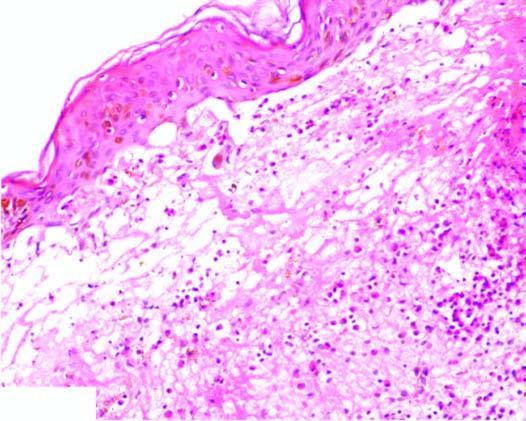do the lumen show neutrophilic microabscess causing dermo-epidermal separation at tips?
Answer the question using a single word or phrase. No 